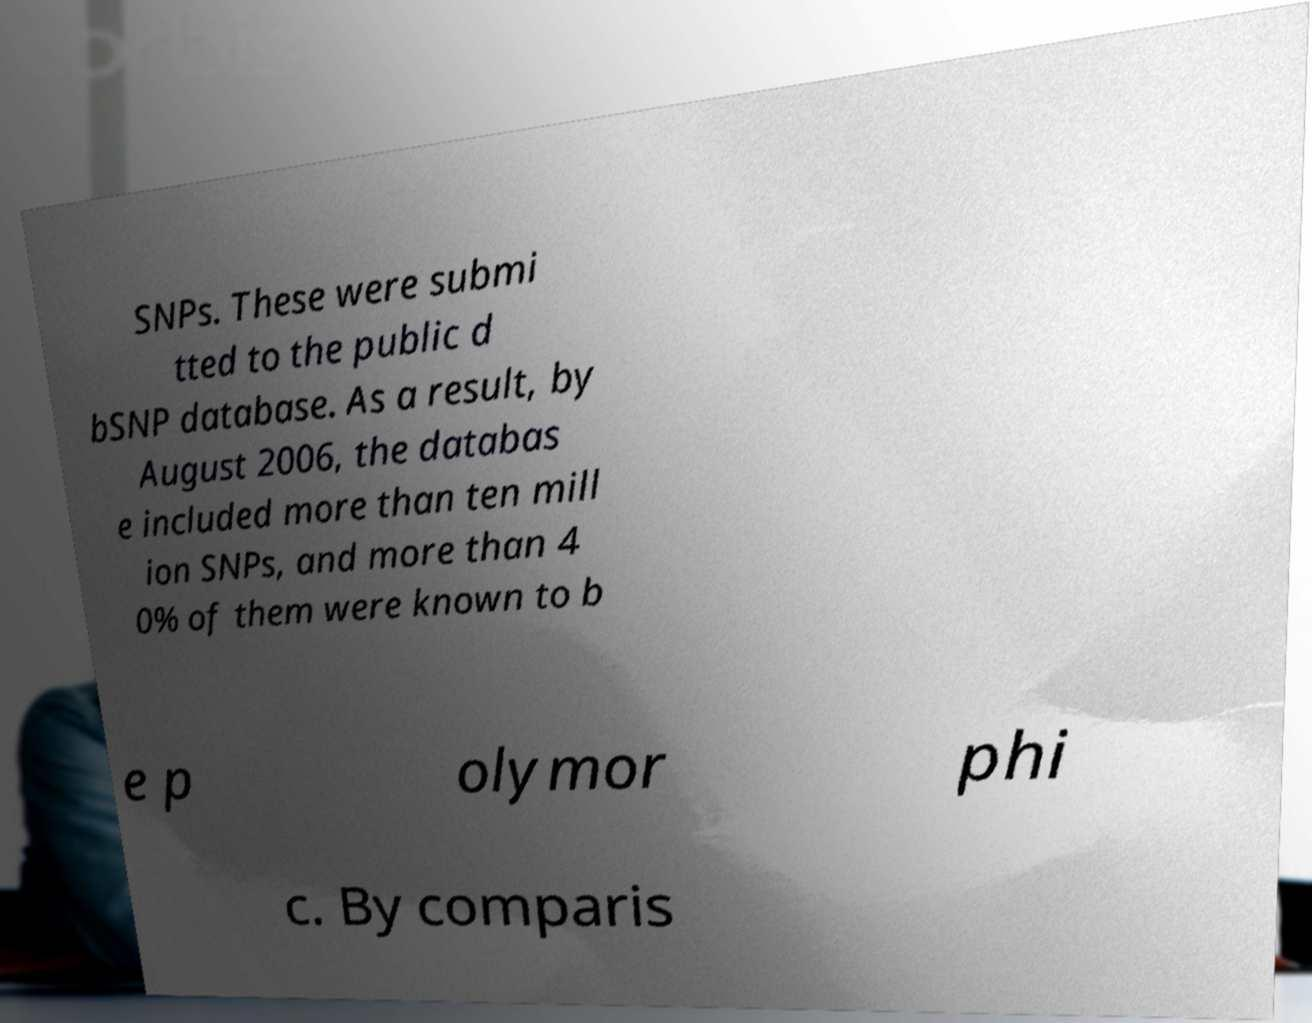Can you accurately transcribe the text from the provided image for me? SNPs. These were submi tted to the public d bSNP database. As a result, by August 2006, the databas e included more than ten mill ion SNPs, and more than 4 0% of them were known to b e p olymor phi c. By comparis 